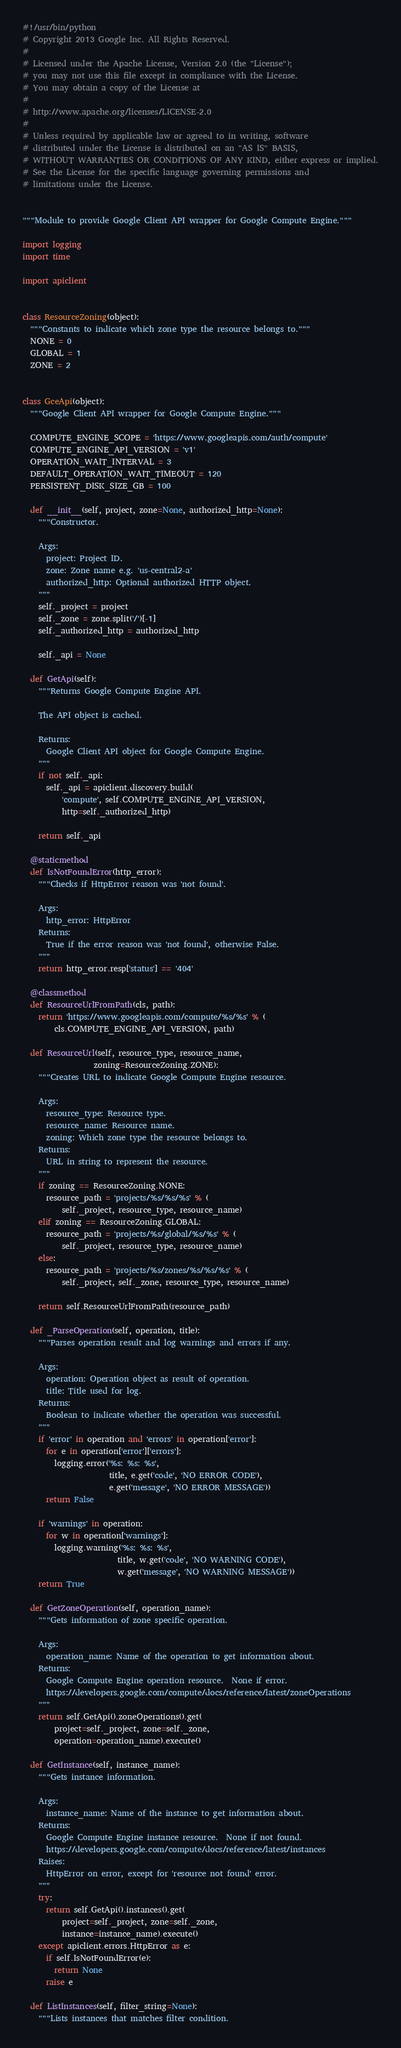Convert code to text. <code><loc_0><loc_0><loc_500><loc_500><_Python_>#!/usr/bin/python
# Copyright 2013 Google Inc. All Rights Reserved.
# 
# Licensed under the Apache License, Version 2.0 (the "License");
# you may not use this file except in compliance with the License.
# You may obtain a copy of the License at
# 
# http://www.apache.org/licenses/LICENSE-2.0
# 
# Unless required by applicable law or agreed to in writing, software
# distributed under the License is distributed on an "AS IS" BASIS,
# WITHOUT WARRANTIES OR CONDITIONS OF ANY KIND, either express or implied.
# See the License for the specific language governing permissions and
# limitations under the License.


"""Module to provide Google Client API wrapper for Google Compute Engine."""

import logging
import time

import apiclient


class ResourceZoning(object):
  """Constants to indicate which zone type the resource belongs to."""
  NONE = 0
  GLOBAL = 1
  ZONE = 2


class GceApi(object):
  """Google Client API wrapper for Google Compute Engine."""

  COMPUTE_ENGINE_SCOPE = 'https://www.googleapis.com/auth/compute'
  COMPUTE_ENGINE_API_VERSION = 'v1'
  OPERATION_WAIT_INTERVAL = 3
  DEFAULT_OPERATION_WAIT_TIMEOUT = 120
  PERSISTENT_DISK_SIZE_GB = 100

  def __init__(self, project, zone=None, authorized_http=None):
    """Constructor.

    Args:
      project: Project ID.
      zone: Zone name e.g. 'us-central2-a'
      authorized_http: Optional authorized HTTP object.
    """
    self._project = project
    self._zone = zone.split('/')[-1]
    self._authorized_http = authorized_http

    self._api = None

  def GetApi(self):
    """Returns Google Compute Engine API.

    The API object is cached.

    Returns:
      Google Client API object for Google Compute Engine.
    """
    if not self._api:
      self._api = apiclient.discovery.build(
          'compute', self.COMPUTE_ENGINE_API_VERSION,
          http=self._authorized_http)

    return self._api

  @staticmethod
  def IsNotFoundError(http_error):
    """Checks if HttpError reason was 'not found'.

    Args:
      http_error: HttpError
    Returns:
      True if the error reason was 'not found', otherwise False.
    """
    return http_error.resp['status'] == '404'

  @classmethod
  def ResourceUrlFromPath(cls, path):
    return 'https://www.googleapis.com/compute/%s/%s' % (
        cls.COMPUTE_ENGINE_API_VERSION, path)

  def ResourceUrl(self, resource_type, resource_name,
                  zoning=ResourceZoning.ZONE):
    """Creates URL to indicate Google Compute Engine resource.

    Args:
      resource_type: Resource type.
      resource_name: Resource name.
      zoning: Which zone type the resource belongs to.
    Returns:
      URL in string to represent the resource.
    """
    if zoning == ResourceZoning.NONE:
      resource_path = 'projects/%s/%s/%s' % (
          self._project, resource_type, resource_name)
    elif zoning == ResourceZoning.GLOBAL:
      resource_path = 'projects/%s/global/%s/%s' % (
          self._project, resource_type, resource_name)
    else:
      resource_path = 'projects/%s/zones/%s/%s/%s' % (
          self._project, self._zone, resource_type, resource_name)

    return self.ResourceUrlFromPath(resource_path)

  def _ParseOperation(self, operation, title):
    """Parses operation result and log warnings and errors if any.

    Args:
      operation: Operation object as result of operation.
      title: Title used for log.
    Returns:
      Boolean to indicate whether the operation was successful.
    """
    if 'error' in operation and 'errors' in operation['error']:
      for e in operation['error']['errors']:
        logging.error('%s: %s: %s',
                      title, e.get('code', 'NO ERROR CODE'),
                      e.get('message', 'NO ERROR MESSAGE'))
      return False

    if 'warnings' in operation:
      for w in operation['warnings']:
        logging.warning('%s: %s: %s',
                        title, w.get('code', 'NO WARNING CODE'),
                        w.get('message', 'NO WARNING MESSAGE'))
    return True

  def GetZoneOperation(self, operation_name):
    """Gets information of zone specific operation.

    Args:
      operation_name: Name of the operation to get information about.
    Returns:
      Google Compute Engine operation resource.  None if error.
      https://developers.google.com/compute/docs/reference/latest/zoneOperations
    """
    return self.GetApi().zoneOperations().get(
        project=self._project, zone=self._zone,
        operation=operation_name).execute()

  def GetInstance(self, instance_name):
    """Gets instance information.

    Args:
      instance_name: Name of the instance to get information about.
    Returns:
      Google Compute Engine instance resource.  None if not found.
      https://developers.google.com/compute/docs/reference/latest/instances
    Raises:
      HttpError on error, except for 'resource not found' error.
    """
    try:
      return self.GetApi().instances().get(
          project=self._project, zone=self._zone,
          instance=instance_name).execute()
    except apiclient.errors.HttpError as e:
      if self.IsNotFoundError(e):
        return None
      raise e

  def ListInstances(self, filter_string=None):
    """Lists instances that matches filter condition.
</code> 